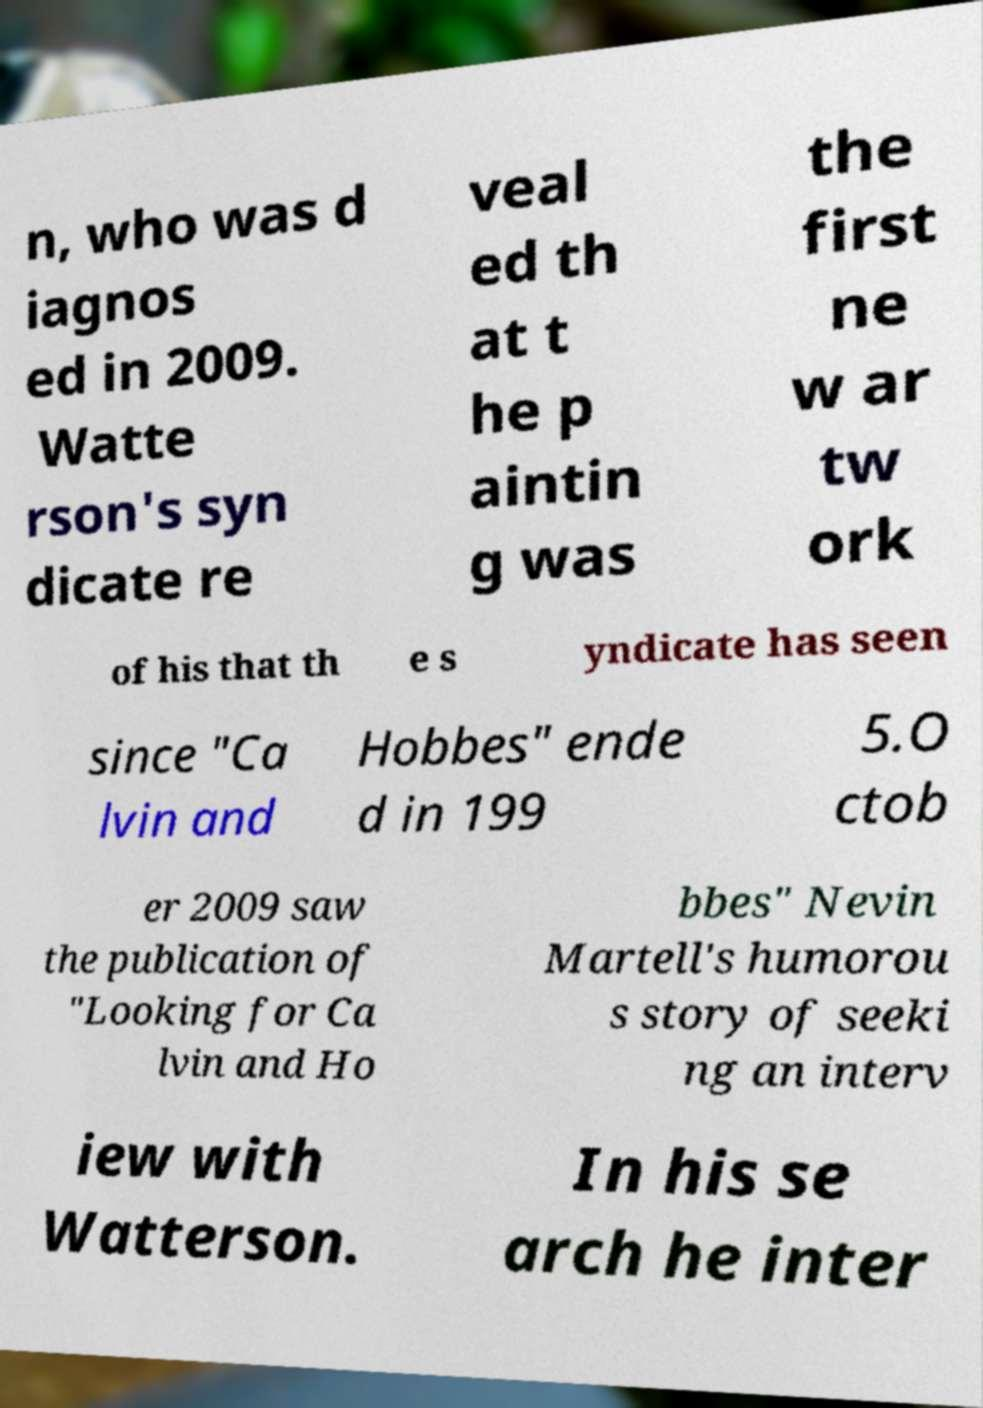I need the written content from this picture converted into text. Can you do that? n, who was d iagnos ed in 2009. Watte rson's syn dicate re veal ed th at t he p aintin g was the first ne w ar tw ork of his that th e s yndicate has seen since "Ca lvin and Hobbes" ende d in 199 5.O ctob er 2009 saw the publication of "Looking for Ca lvin and Ho bbes" Nevin Martell's humorou s story of seeki ng an interv iew with Watterson. In his se arch he inter 